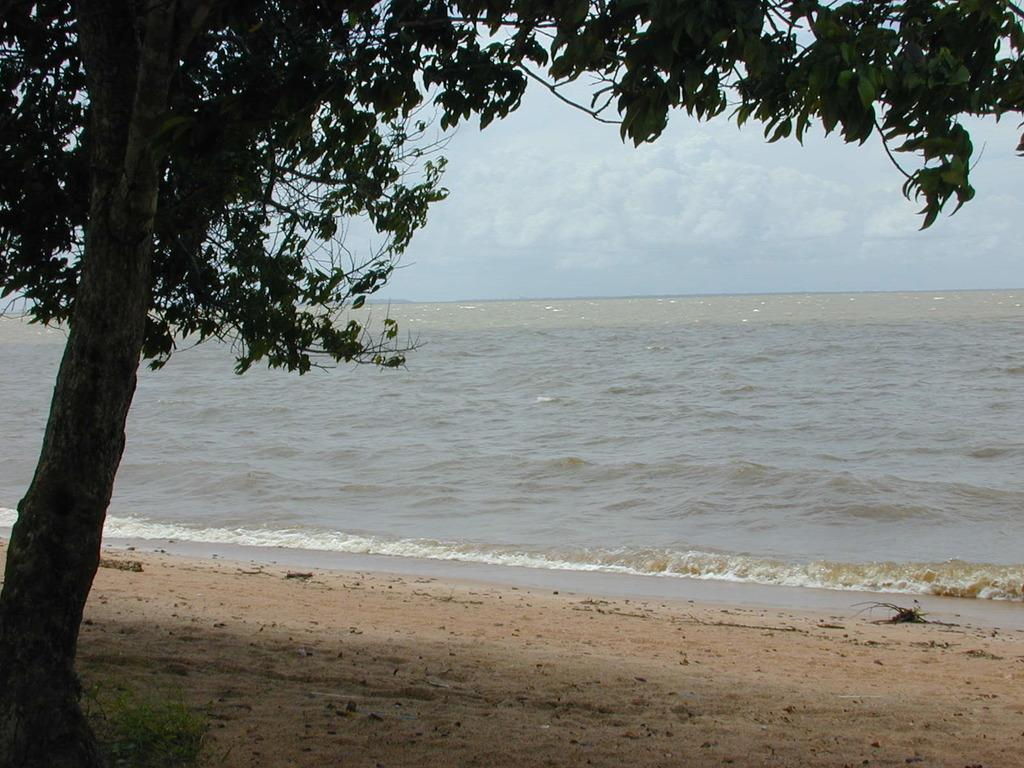What type of location is depicted in the image? The image appears to be a seashore. What can be seen in the water in the image? There is water flowing in the image. What type of plant is present in the image? There is a tree with branches and leaves in the image. What is the purpose of the crown in the image? There is no crown present in the image. 